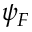<formula> <loc_0><loc_0><loc_500><loc_500>\psi _ { F }</formula> 